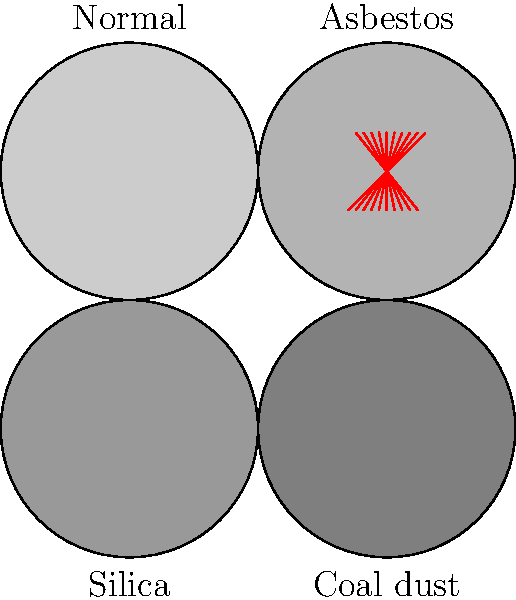Based on the visual representation of lung tissue exposed to various airborne particles, which type of exposure appears to have the least impact on lung tissue structure compared to normal tissue? To answer this question, we need to analyze the visual representation of lung tissue exposed to different airborne particles:

1. Normal tissue: Shown in the top-left quadrant, it has a uniform light gray color, representing healthy lung tissue.

2. Asbestos exposure: Shown in the top-right quadrant, it contains visible red fibers scattered throughout the tissue. These fibers represent asbestos fibers, which can cause significant damage to lung tissue over time.

3. Silica exposure: Shown in the bottom-left quadrant, it contains small black dots representing silica particles. These particles can cause inflammation and scarring in lung tissue.

4. Coal dust exposure: Shown in the bottom-right quadrant, it also contains small black dots representing coal dust particles. Like silica, coal dust can cause inflammation and scarring.

Comparing the exposed tissues to the normal tissue:

- Asbestos exposure shows the most visible change with the presence of red fibers.
- Both silica and coal dust exposures show similar levels of particle accumulation.

Among the exposed tissues, the asbestos exposure appears to have the most visually distinct impact due to the presence of fibers. The silica and coal dust exposures show similar levels of particle accumulation, which may lead to comparable tissue changes over time.

However, it's important to note that this visual representation doesn't fully capture the long-term health effects of these exposures. In reality, all of these particles can cause significant damage to lung tissue over time.
Answer: None; all exposures impact lung tissue structure. 